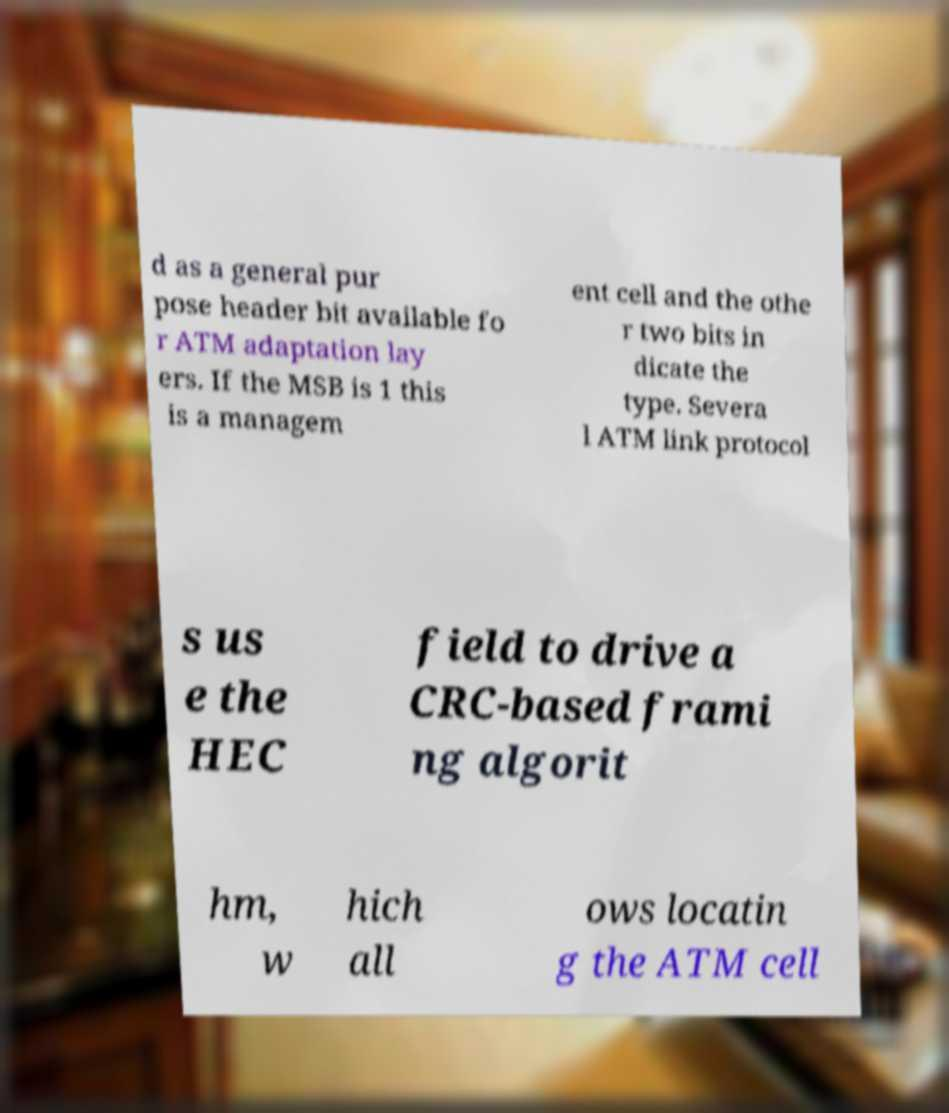I need the written content from this picture converted into text. Can you do that? d as a general pur pose header bit available fo r ATM adaptation lay ers. If the MSB is 1 this is a managem ent cell and the othe r two bits in dicate the type. Severa l ATM link protocol s us e the HEC field to drive a CRC-based frami ng algorit hm, w hich all ows locatin g the ATM cell 